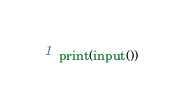Convert code to text. <code><loc_0><loc_0><loc_500><loc_500><_Python_>print(input())</code> 